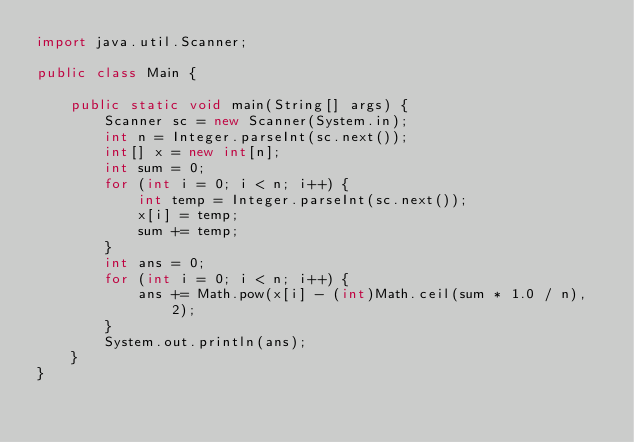Convert code to text. <code><loc_0><loc_0><loc_500><loc_500><_Java_>import java.util.Scanner;

public class Main {

    public static void main(String[] args) {
        Scanner sc = new Scanner(System.in);
        int n = Integer.parseInt(sc.next());
        int[] x = new int[n];
        int sum = 0;
        for (int i = 0; i < n; i++) {
            int temp = Integer.parseInt(sc.next());
            x[i] = temp;
            sum += temp;
        }
        int ans = 0;
        for (int i = 0; i < n; i++) {
            ans += Math.pow(x[i] - (int)Math.ceil(sum * 1.0 / n), 2);
        }
        System.out.println(ans);
    }
}</code> 